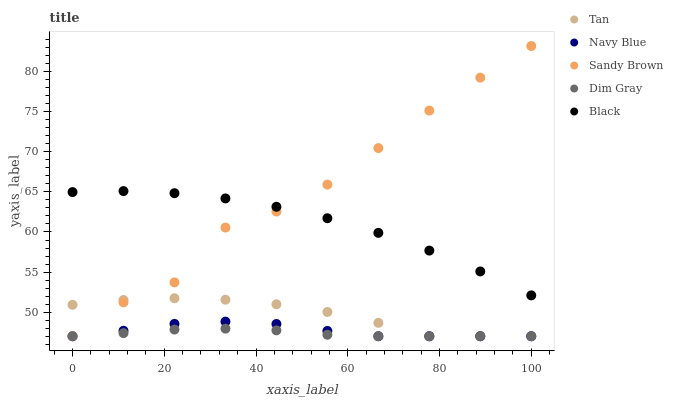Does Dim Gray have the minimum area under the curve?
Answer yes or no. Yes. Does Sandy Brown have the maximum area under the curve?
Answer yes or no. Yes. Does Tan have the minimum area under the curve?
Answer yes or no. No. Does Tan have the maximum area under the curve?
Answer yes or no. No. Is Dim Gray the smoothest?
Answer yes or no. Yes. Is Sandy Brown the roughest?
Answer yes or no. Yes. Is Tan the smoothest?
Answer yes or no. No. Is Tan the roughest?
Answer yes or no. No. Does Navy Blue have the lowest value?
Answer yes or no. Yes. Does Black have the lowest value?
Answer yes or no. No. Does Sandy Brown have the highest value?
Answer yes or no. Yes. Does Tan have the highest value?
Answer yes or no. No. Is Dim Gray less than Black?
Answer yes or no. Yes. Is Black greater than Navy Blue?
Answer yes or no. Yes. Does Tan intersect Sandy Brown?
Answer yes or no. Yes. Is Tan less than Sandy Brown?
Answer yes or no. No. Is Tan greater than Sandy Brown?
Answer yes or no. No. Does Dim Gray intersect Black?
Answer yes or no. No. 